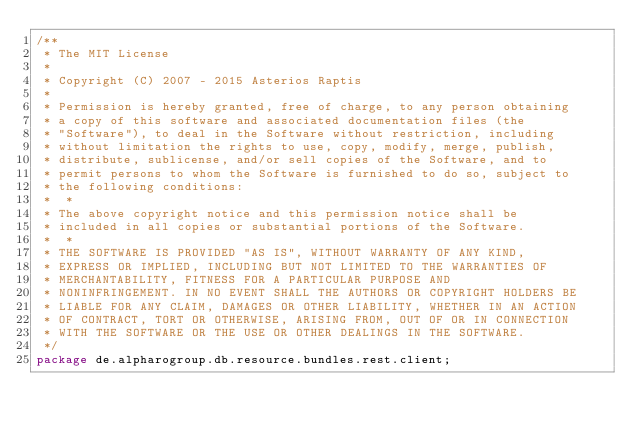<code> <loc_0><loc_0><loc_500><loc_500><_Java_>/**
 * The MIT License
 *
 * Copyright (C) 2007 - 2015 Asterios Raptis
 *
 * Permission is hereby granted, free of charge, to any person obtaining
 * a copy of this software and associated documentation files (the
 * "Software"), to deal in the Software without restriction, including
 * without limitation the rights to use, copy, modify, merge, publish,
 * distribute, sublicense, and/or sell copies of the Software, and to
 * permit persons to whom the Software is furnished to do so, subject to
 * the following conditions:
 *  *
 * The above copyright notice and this permission notice shall be
 * included in all copies or substantial portions of the Software.
 *  *
 * THE SOFTWARE IS PROVIDED "AS IS", WITHOUT WARRANTY OF ANY KIND,
 * EXPRESS OR IMPLIED, INCLUDING BUT NOT LIMITED TO THE WARRANTIES OF
 * MERCHANTABILITY, FITNESS FOR A PARTICULAR PURPOSE AND
 * NONINFRINGEMENT. IN NO EVENT SHALL THE AUTHORS OR COPYRIGHT HOLDERS BE
 * LIABLE FOR ANY CLAIM, DAMAGES OR OTHER LIABILITY, WHETHER IN AN ACTION
 * OF CONTRACT, TORT OR OTHERWISE, ARISING FROM, OUT OF OR IN CONNECTION
 * WITH THE SOFTWARE OR THE USE OR OTHER DEALINGS IN THE SOFTWARE.
 */
package de.alpharogroup.db.resource.bundles.rest.client;
</code> 